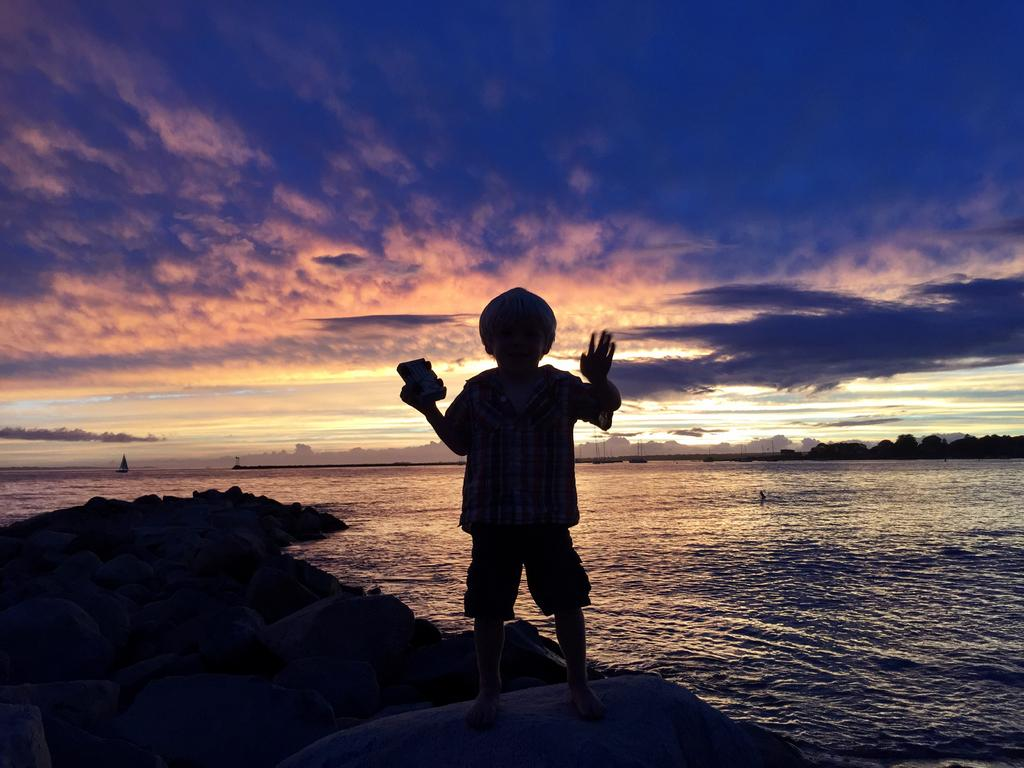What is the main subject in the middle of the image? There is a boy in the middle of the image. What is located at the bottom of the image? There is a boat at the bottom of the image. What type of terrain can be seen in the image? Land is visible in the image. Can you describe the background of the image? In the background, there are boats, water, hills, trees, the sky, and clouds. What type of sense can be seen in the image? There is no sense present in the image; it is a visual representation of a scene. Is there any wax visible in the image? There is no wax present in the image. 